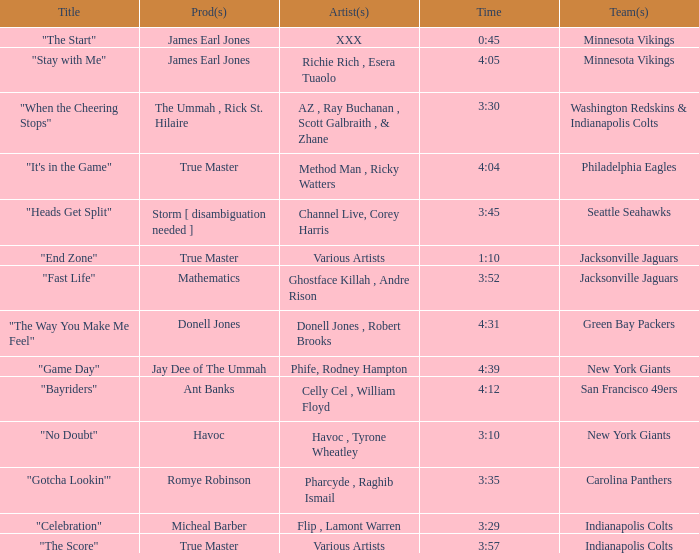What teams used a track 3:29 long? Indianapolis Colts. 